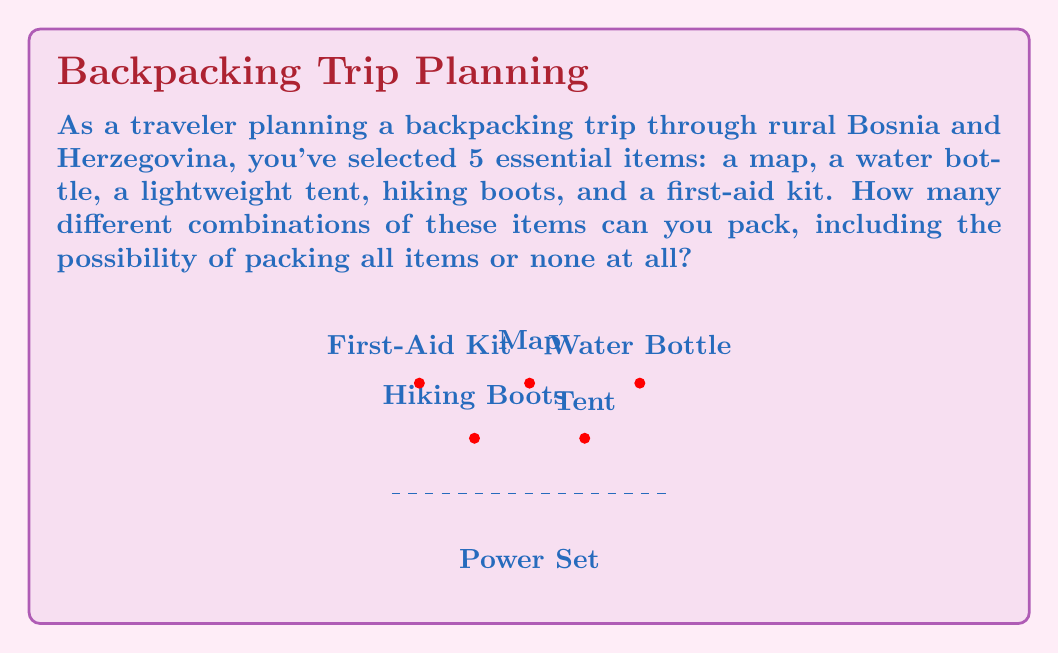Can you answer this question? Let's approach this step-by-step using set theory:

1) First, we need to understand what the question is asking. We're looking for the number of all possible combinations of these items, which is equivalent to finding the cardinality of the power set of our set of items.

2) The power set of a set $S$ is the set of all subsets of $S$, including the empty set and $S$ itself.

3) For a set with $n$ elements, the number of elements in its power set is given by $2^n$.

4) In our case, we have 5 items:
   $S = \text{\{map, water bottle, lightweight tent, hiking boots, first-aid kit\}}$

5) Therefore, $n = 5$

6) The number of elements in the power set is:

   $|P(S)| = 2^n = 2^5 = 32$

This means there are 32 different combinations of items you can pack, including packing nothing (empty set) and packing all items (the full set $S$).

To verify, we can list out a few combinations:
- {} (empty set, packing nothing)
- {map}
- {water bottle}
- {map, water bottle}
- {map, water bottle, lightweight tent}
...
- {map, water bottle, lightweight tent, hiking boots, first-aid kit} (full set $S$)

Each item can either be in the subset (packed) or not, giving us 2 choices for each of the 5 items, resulting in $2 * 2 * 2 * 2 * 2 = 2^5 = 32$ total combinations.
Answer: $32$ 